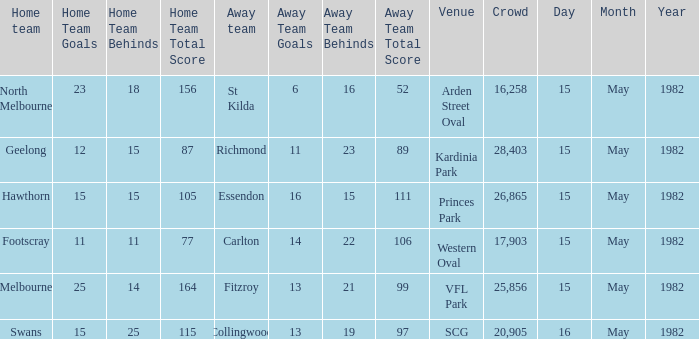Can you give me this table as a dict? {'header': ['Home team', 'Home Team Goals', 'Home Team Behinds', 'Home Team Total Score', 'Away team', 'Away Team Goals', 'Away Team Behinds', 'Away Team Total Score', 'Venue', 'Crowd', 'Day', 'Month', 'Year'], 'rows': [['North Melbourne', '23', '18', '156', 'St Kilda', '6', '16', '52', 'Arden Street Oval', '16,258', '15', 'May', '1982'], ['Geelong', '12', '15', '87', 'Richmond', '11', '23', '89', 'Kardinia Park', '28,403', '15', 'May', '1982'], ['Hawthorn', '15', '15', '105', 'Essendon', '16', '15', '111', 'Princes Park', '26,865', '15', 'May', '1982'], ['Footscray', '11', '11', '77', 'Carlton', '14', '22', '106', 'Western Oval', '17,903', '15', 'May', '1982'], ['Melbourne', '25', '14', '164', 'Fitzroy', '13', '21', '99', 'VFL Park', '25,856', '15', 'May', '1982'], ['Swans', '15', '25', '115', 'Collingwood', '13', '19', '97', 'SCG', '20,905', '16', 'May', '1982']]} At which location did geelong participate as the home team? Kardinia Park. 